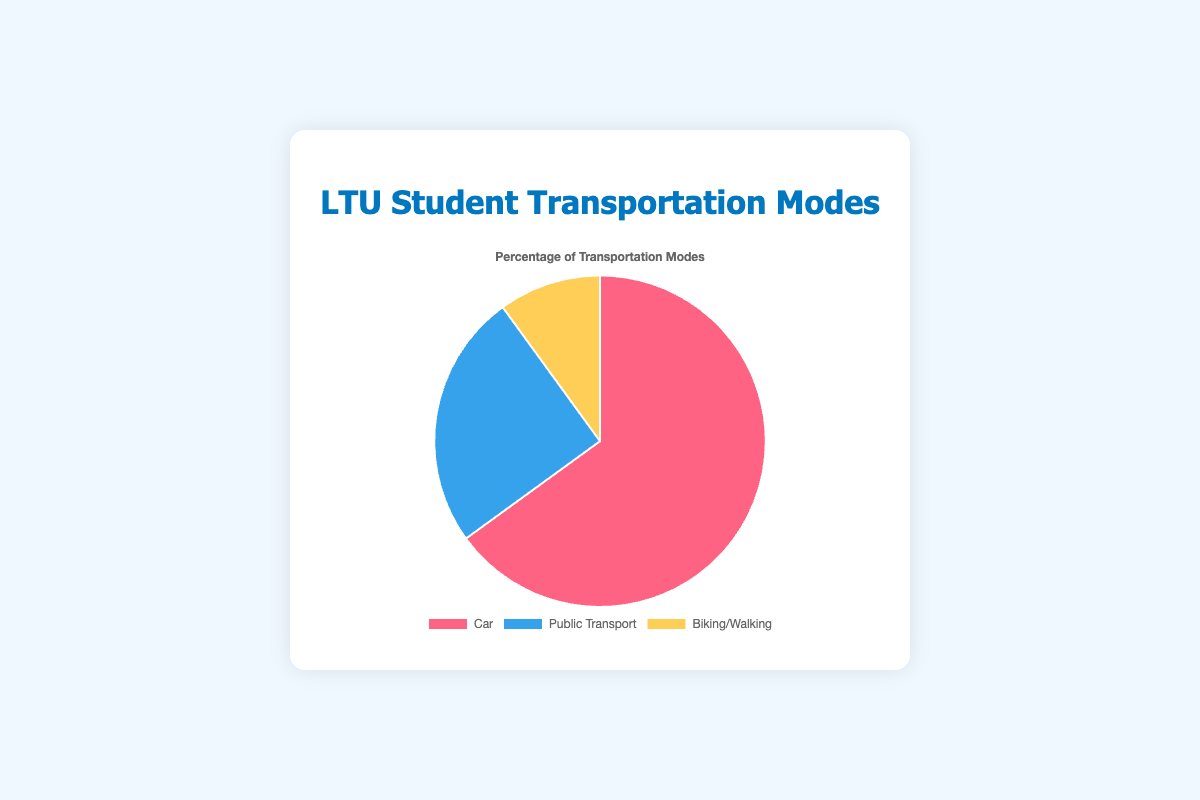Which mode of transportation has the highest percentage? The pie chart shows a breakdown of different modes of transportation. The color-coded segments indicate the share of each mode. By looking at the largest segment, you can see that Car transportation has the highest percentage.
Answer: Car What is the total percentage of students using either car or public transport? To find the total percentage of students using either car or public transport, sum the percentages for these two modes: 65% (Car) + 25% (Public Transport).
Answer: 90% How does the percentage of students using biking/walking compare to those using public transport? Compare the percentages of the two transportation modes given in the chart: Biking/Walking is 10%, and Public Transport is 25%. Since 10% is less than 25%, fewer students use biking/walking compared to public transport.
Answer: Less What percentage of students do not use a car to get to campus? Subtract the percentage of students using a car from the total percentage (100%): 100% - 65% = 35%. This includes both public transport and biking/walking users.
Answer: 35% Which color represents the mode of transportation with the smallest percentage? Referring to the visual attributes of the pie chart, the smallest segment is usually the least percentage. According to the data, 10% (Biking/Walking) is the smallest, represented by the yellow segment in the chart.
Answer: Yellow What is the ratio of students using cars to those using biking/walking? Use the given percentages to form a ratio: 65% (Car) to 10% (Biking/Walking). The ratio is 65/10, which simplifies to 6.5 to 1.
Answer: 6.5 to 1 By how much does the percentage of students using public transport exceed those using biking/walking? Subtract the percentage of biking/walking from public transport: 25% (Public Transport) - 10% (Biking/Walking) = 15%.
Answer: 15% What is the combined percentage of students using either public transport or biking/walking? Add the percentages for public transport and biking/walking: 25% (Public Transport) + 10% (Biking/Walking) = 35%.
Answer: 35% How many times greater is the percentage of car users compared to biking/walking users? Divide the percentage of car users by the percentage of biking/walking users: 65% / 10% = 6.5. So, the percentage is 6.5 times greater.
Answer: 6.5 times If there were 200 students surveyed, how many of them use public transport? Multiply the total number of surveyed students by the percentage using public transport: 200 * 0.25 = 50 students.
Answer: 50 